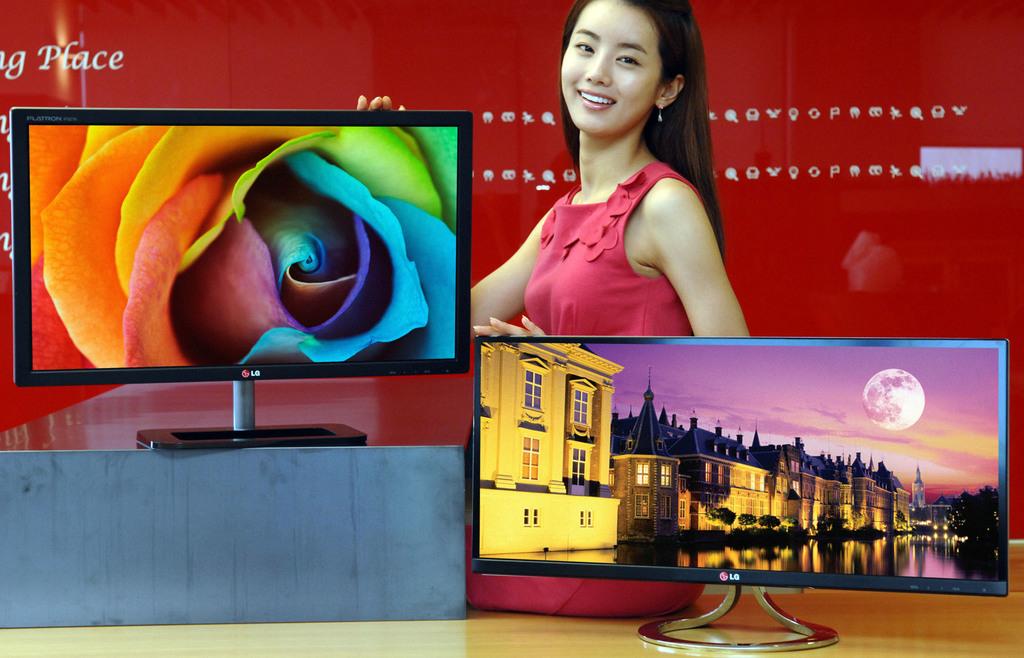What is the word in the upper-left hand corner, right above the tv with the flower?
Provide a short and direct response. Place. What brand of monitors are these"?
Ensure brevity in your answer.  Lg. 